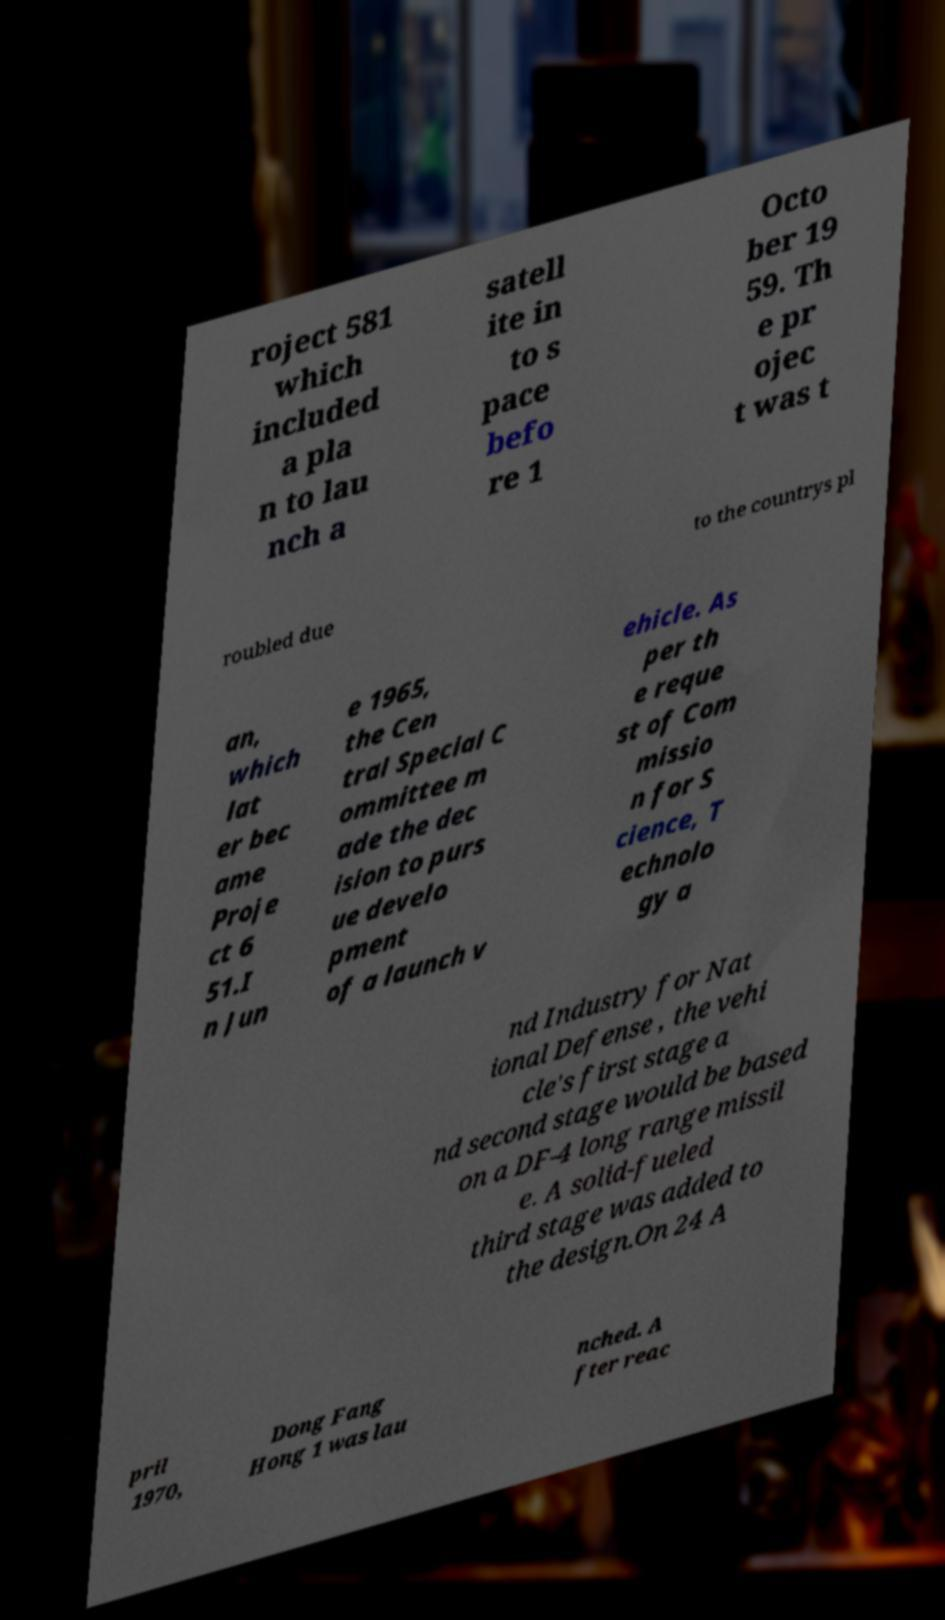What messages or text are displayed in this image? I need them in a readable, typed format. roject 581 which included a pla n to lau nch a satell ite in to s pace befo re 1 Octo ber 19 59. Th e pr ojec t was t roubled due to the countrys pl an, which lat er bec ame Proje ct 6 51.I n Jun e 1965, the Cen tral Special C ommittee m ade the dec ision to purs ue develo pment of a launch v ehicle. As per th e reque st of Com missio n for S cience, T echnolo gy a nd Industry for Nat ional Defense , the vehi cle's first stage a nd second stage would be based on a DF-4 long range missil e. A solid-fueled third stage was added to the design.On 24 A pril 1970, Dong Fang Hong 1 was lau nched. A fter reac 